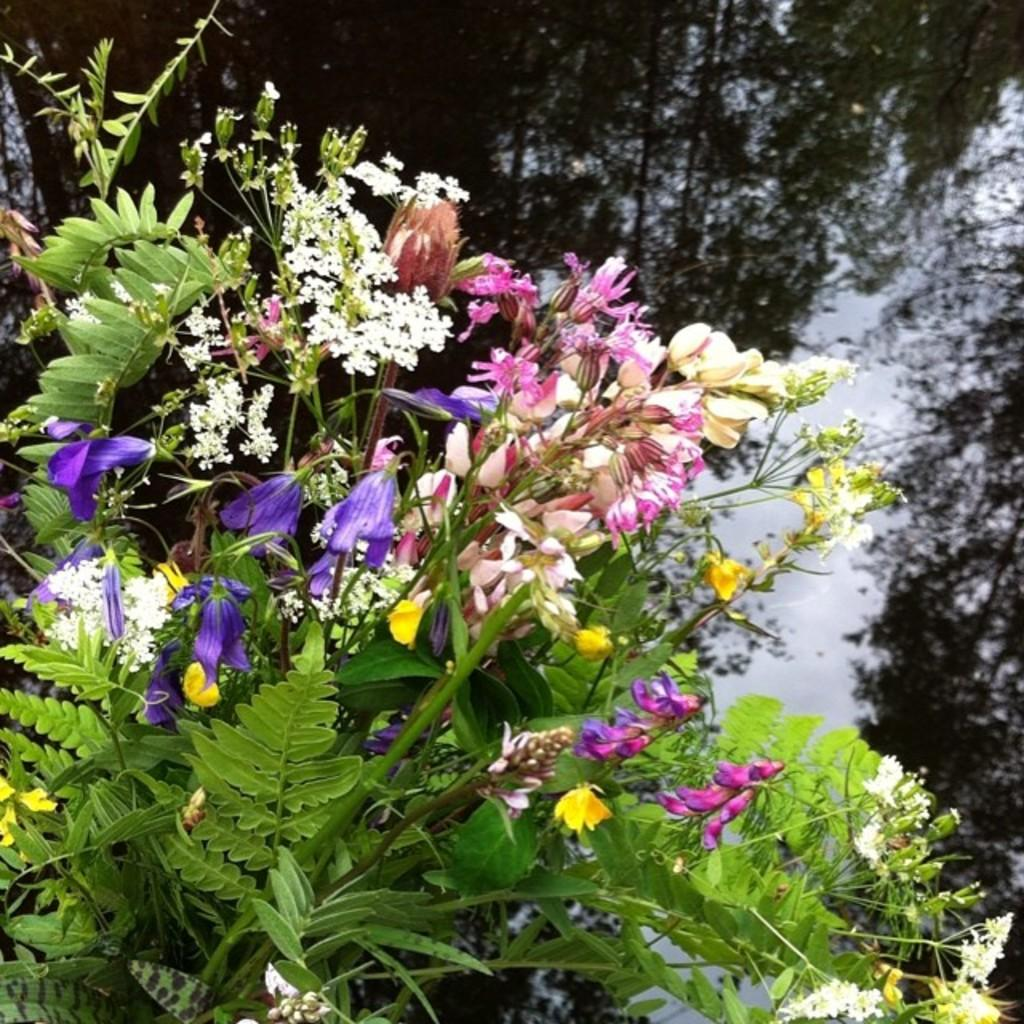What is located in the front of the image? There are plants and flowers in the front of the image. What can be seen in the background of the image? There is water visible in the background of the image. What is reflected on the water in the image? The reflection of trees can be seen on the water. What type of hall is visible in the image? There is no hall present in the image; it features plants, flowers, water, and the reflection of trees. 